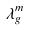Convert formula to latex. <formula><loc_0><loc_0><loc_500><loc_500>\lambda _ { g } ^ { m }</formula> 